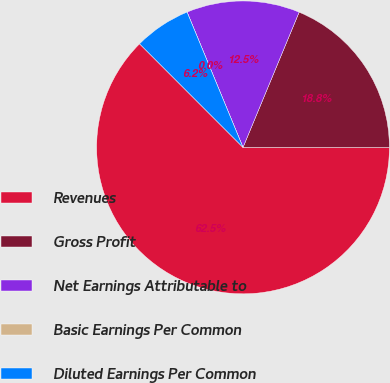Convert chart. <chart><loc_0><loc_0><loc_500><loc_500><pie_chart><fcel>Revenues<fcel>Gross Profit<fcel>Net Earnings Attributable to<fcel>Basic Earnings Per Common<fcel>Diluted Earnings Per Common<nl><fcel>62.5%<fcel>18.75%<fcel>12.5%<fcel>0.0%<fcel>6.25%<nl></chart> 